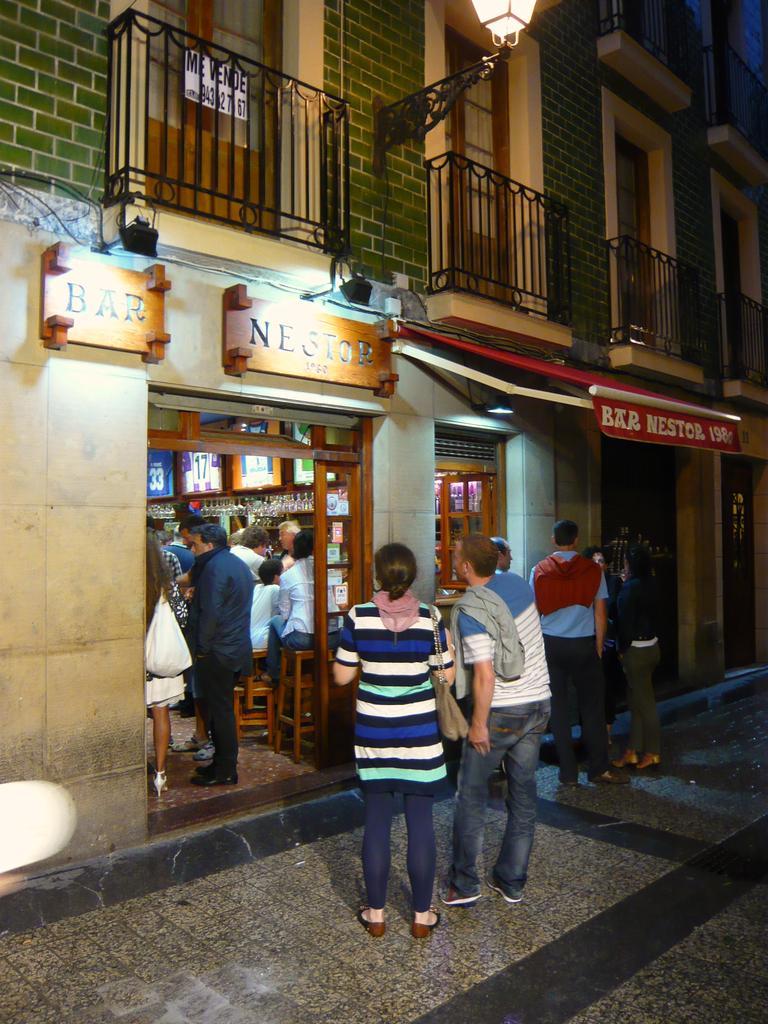In one or two sentences, can you explain what this image depicts? In this picture we can see people on the ground, here we can see a building, name boards and some objects. 